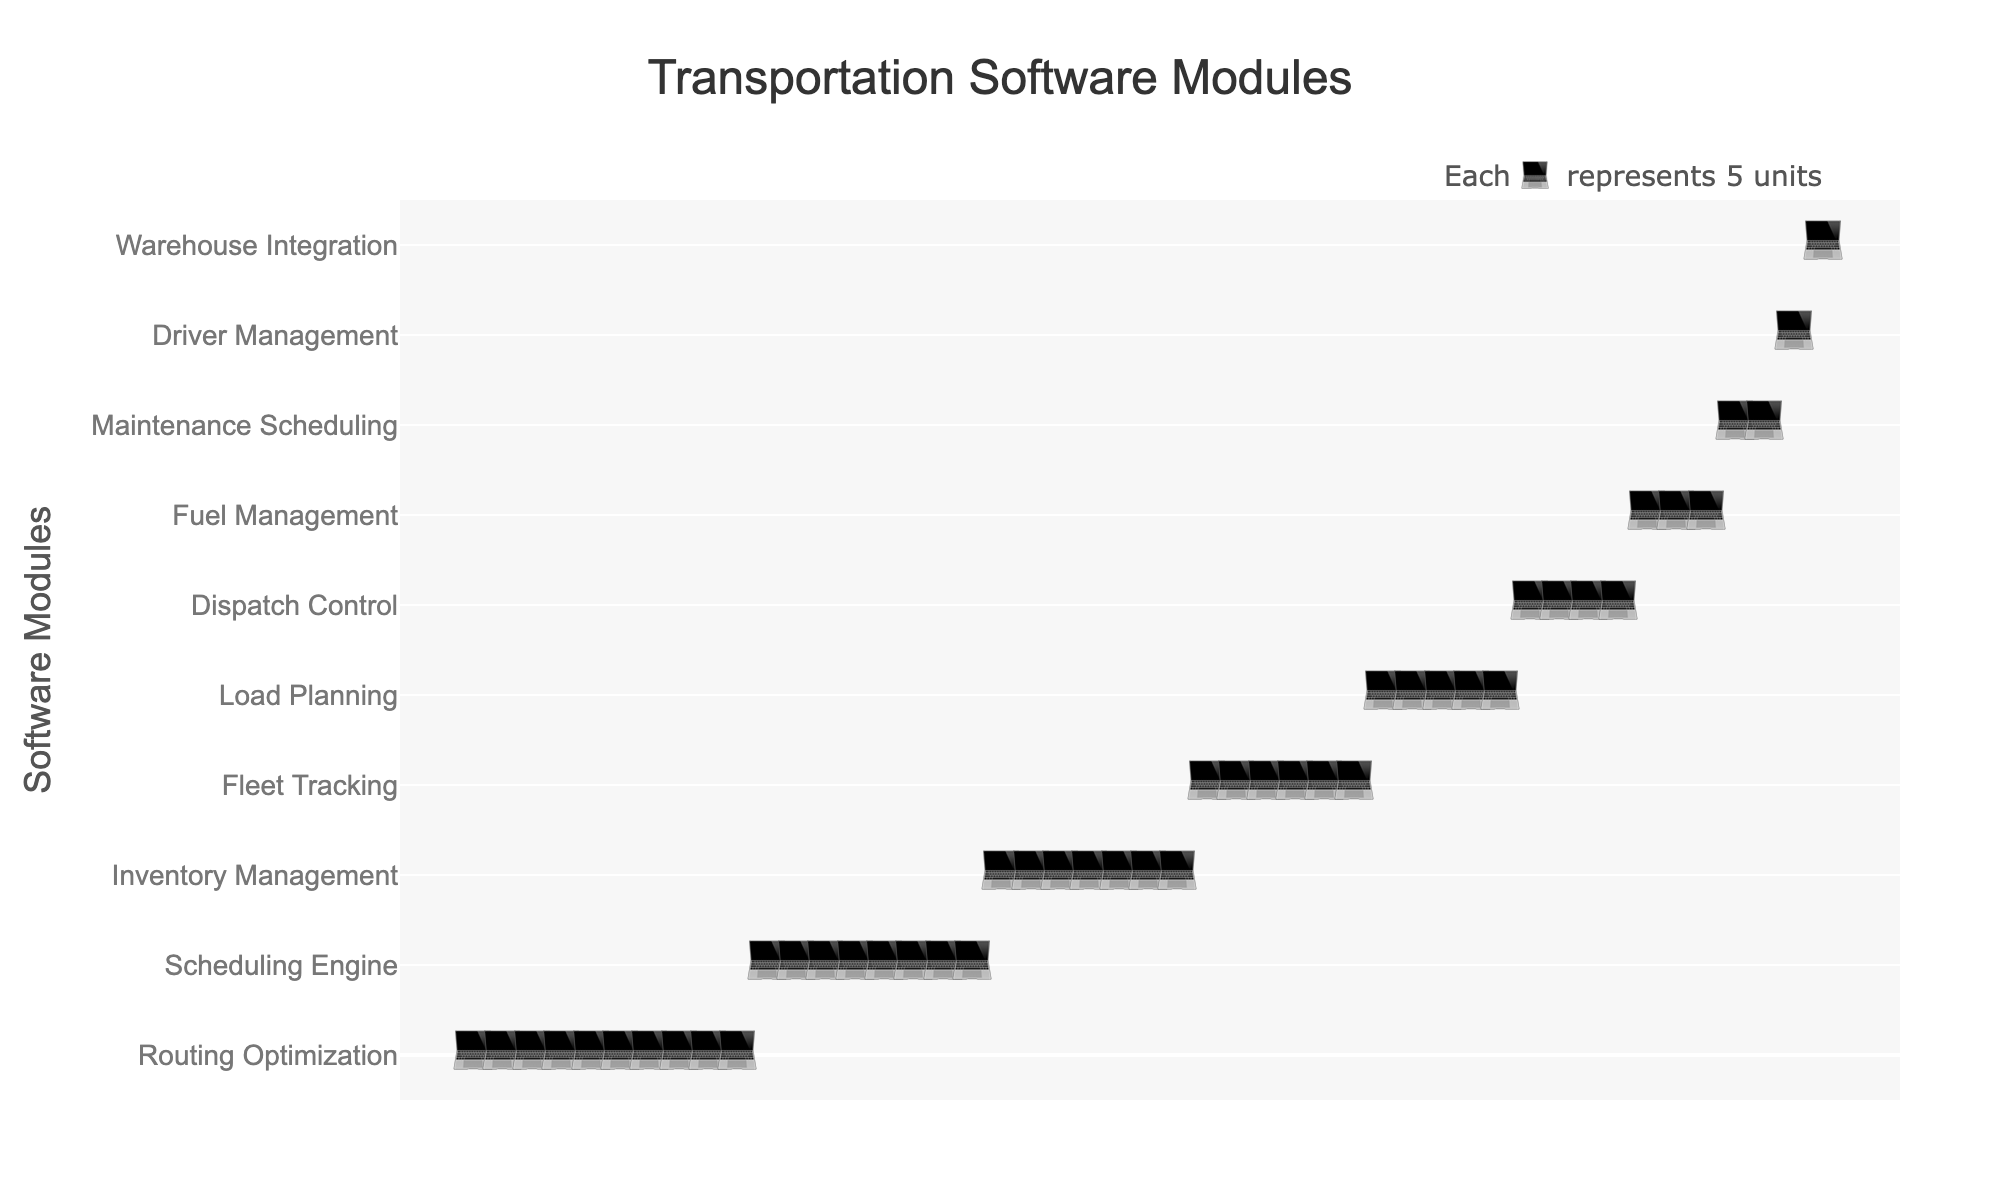Which module has the highest count of units? The largest count can be identified by observing the module with the highest number of icons.
Answer: Routing Optimization What is the total count of units for Fleet Tracking and Load Planning combined? Fleet Tracking has 6 icons, each representing 5 units, thus 6 * 5 = 30. Load Planning has 5 icons, each representing 5 units, thus 5 * 5 = 25. So, 30 + 25 = 55 units in total.
Answer: 55 How many fewer units does Driver Management have compared to Scheduling Engine? Scheduling Engine has 8 icons (40 units) and Driver Management has 1 icon (8 units). The difference is 40 - 8 = 32 units.
Answer: 32 Which modules have more than 25 units? Modules with more than 5 icons (each representing 5 units) are Routing Optimization (50 units), Scheduling Engine (40 units), Inventory Management (35 units), and Fleet Tracking (30 units).
Answer: Routing Optimization, Scheduling Engine, Inventory Management, Fleet Tracking How many modules have a unit count of 15 or less? Modules with 3 or fewer icons are Fuel Management (15 units), Maintenance Scheduling (10 units), Driver Management (8 units), and Warehouse Integration (5 units), summing up to 4 modules.
Answer: 4 What is the combined count of the smallest and largest modules? The smallest module is Warehouse Integration with 1 icon (5 units). The largest module is Routing Optimization with 10 icons (50 units). The combined count is 5 + 50 = 55 units.
Answer: 55 What percentage of the total units is represented by Dispatch Control? Dispatch Control has 4 icons, representing 20 units. First, calculate the total number of units: 50 + 40 + 35 + 30 + 25 + 20 + 15 + 10 + 8 + 5 = 238. The percentage is (20 / 238) * 100 = approximately 8.4%.
Answer: 8.4% Which module appears directly below Inventory Management on the y-axis? Based on the sorted order, Inventory Management is followed by Fleet Tracking.
Answer: Fleet Tracking How many modules have counts that are multiples of 10? The modules that meet this criterion are Routing Optimization (50 units), Scheduling Engine (40 units), Fleet Tracking (30 units), Dispatch Control (20 units), and Maintenance Scheduling (10 units), which totals to 5 modules.
Answer: 5 